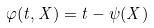<formula> <loc_0><loc_0><loc_500><loc_500>\varphi ( t , X ) = t - \psi ( X )</formula> 